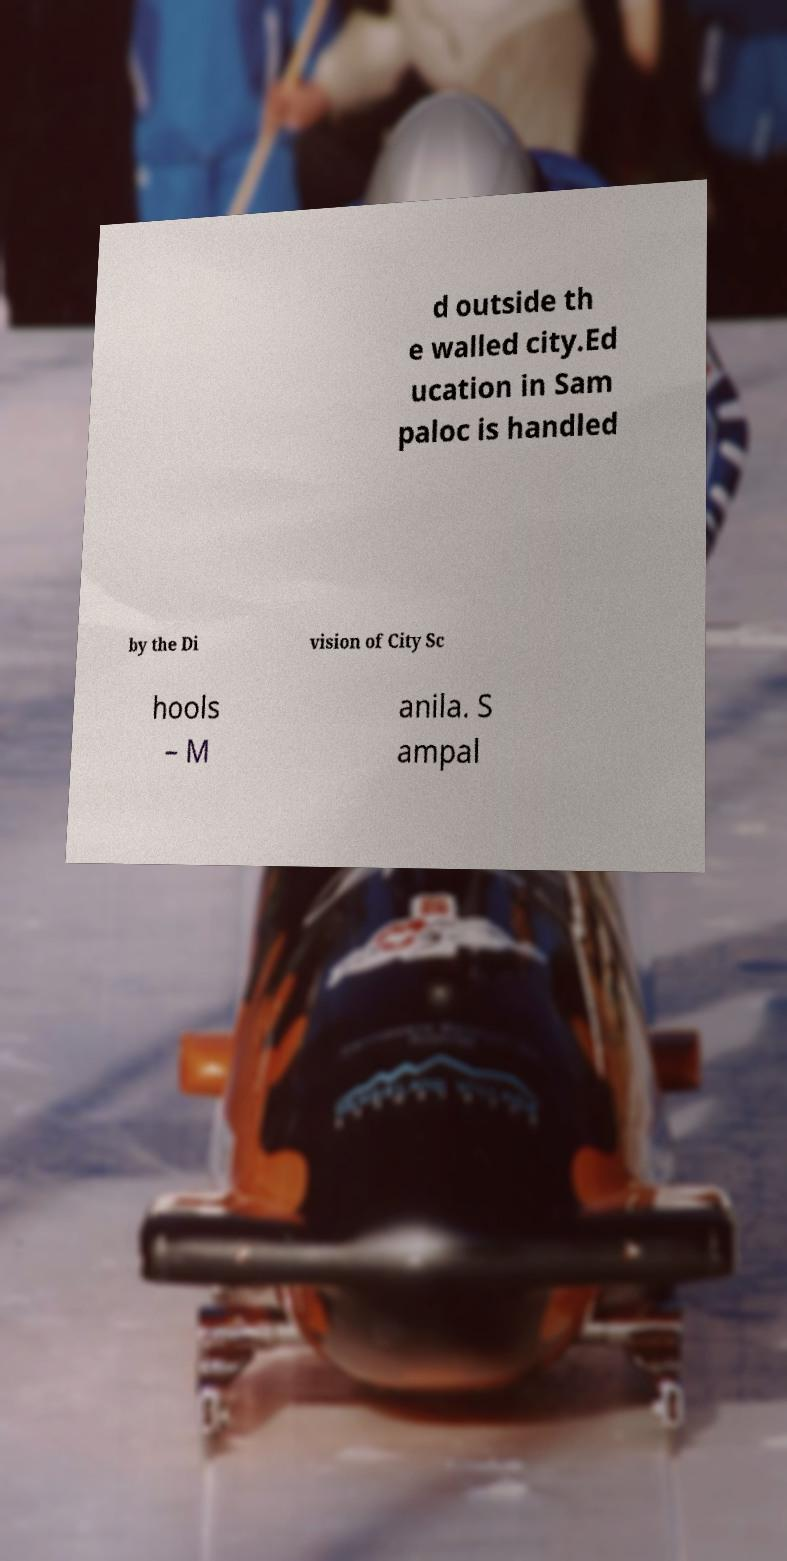Please read and relay the text visible in this image. What does it say? d outside th e walled city.Ed ucation in Sam paloc is handled by the Di vision of City Sc hools – M anila. S ampal 